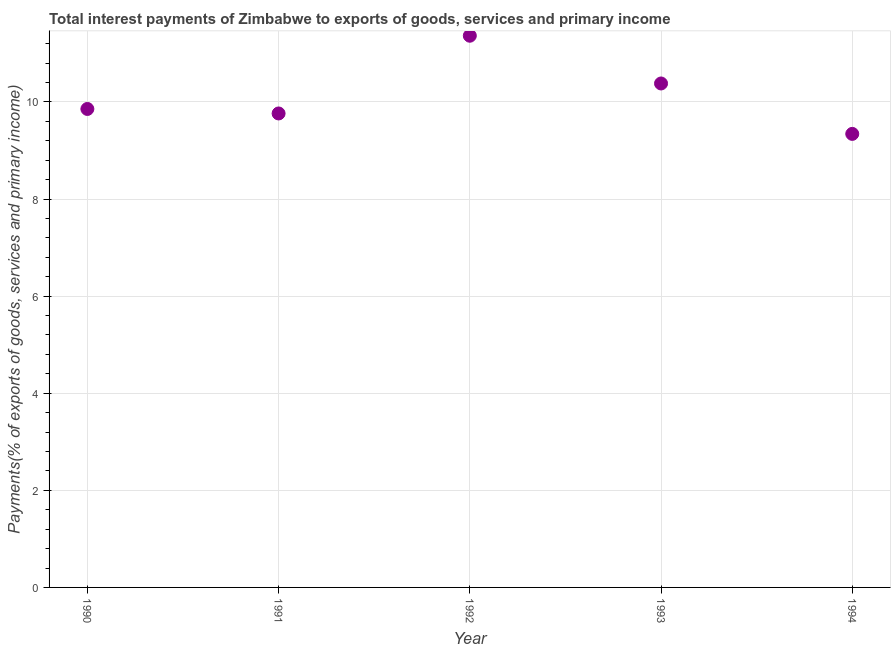What is the total interest payments on external debt in 1990?
Make the answer very short. 9.86. Across all years, what is the maximum total interest payments on external debt?
Your response must be concise. 11.36. Across all years, what is the minimum total interest payments on external debt?
Your answer should be compact. 9.34. In which year was the total interest payments on external debt maximum?
Ensure brevity in your answer.  1992. In which year was the total interest payments on external debt minimum?
Make the answer very short. 1994. What is the sum of the total interest payments on external debt?
Your answer should be very brief. 50.71. What is the difference between the total interest payments on external debt in 1990 and 1993?
Your answer should be compact. -0.53. What is the average total interest payments on external debt per year?
Give a very brief answer. 10.14. What is the median total interest payments on external debt?
Ensure brevity in your answer.  9.86. In how many years, is the total interest payments on external debt greater than 9.2 %?
Give a very brief answer. 5. What is the ratio of the total interest payments on external debt in 1990 to that in 1992?
Give a very brief answer. 0.87. Is the total interest payments on external debt in 1990 less than that in 1993?
Provide a succinct answer. Yes. What is the difference between the highest and the second highest total interest payments on external debt?
Provide a succinct answer. 0.98. Is the sum of the total interest payments on external debt in 1993 and 1994 greater than the maximum total interest payments on external debt across all years?
Offer a terse response. Yes. What is the difference between the highest and the lowest total interest payments on external debt?
Ensure brevity in your answer.  2.02. What is the title of the graph?
Make the answer very short. Total interest payments of Zimbabwe to exports of goods, services and primary income. What is the label or title of the Y-axis?
Your answer should be compact. Payments(% of exports of goods, services and primary income). What is the Payments(% of exports of goods, services and primary income) in 1990?
Make the answer very short. 9.86. What is the Payments(% of exports of goods, services and primary income) in 1991?
Your answer should be compact. 9.76. What is the Payments(% of exports of goods, services and primary income) in 1992?
Your answer should be very brief. 11.36. What is the Payments(% of exports of goods, services and primary income) in 1993?
Ensure brevity in your answer.  10.38. What is the Payments(% of exports of goods, services and primary income) in 1994?
Provide a short and direct response. 9.34. What is the difference between the Payments(% of exports of goods, services and primary income) in 1990 and 1991?
Make the answer very short. 0.09. What is the difference between the Payments(% of exports of goods, services and primary income) in 1990 and 1992?
Provide a short and direct response. -1.51. What is the difference between the Payments(% of exports of goods, services and primary income) in 1990 and 1993?
Your answer should be compact. -0.53. What is the difference between the Payments(% of exports of goods, services and primary income) in 1990 and 1994?
Your answer should be compact. 0.51. What is the difference between the Payments(% of exports of goods, services and primary income) in 1991 and 1992?
Provide a short and direct response. -1.6. What is the difference between the Payments(% of exports of goods, services and primary income) in 1991 and 1993?
Provide a succinct answer. -0.62. What is the difference between the Payments(% of exports of goods, services and primary income) in 1991 and 1994?
Provide a short and direct response. 0.42. What is the difference between the Payments(% of exports of goods, services and primary income) in 1992 and 1993?
Your answer should be very brief. 0.98. What is the difference between the Payments(% of exports of goods, services and primary income) in 1992 and 1994?
Offer a terse response. 2.02. What is the difference between the Payments(% of exports of goods, services and primary income) in 1993 and 1994?
Provide a succinct answer. 1.04. What is the ratio of the Payments(% of exports of goods, services and primary income) in 1990 to that in 1991?
Ensure brevity in your answer.  1.01. What is the ratio of the Payments(% of exports of goods, services and primary income) in 1990 to that in 1992?
Ensure brevity in your answer.  0.87. What is the ratio of the Payments(% of exports of goods, services and primary income) in 1990 to that in 1993?
Your answer should be very brief. 0.95. What is the ratio of the Payments(% of exports of goods, services and primary income) in 1990 to that in 1994?
Make the answer very short. 1.05. What is the ratio of the Payments(% of exports of goods, services and primary income) in 1991 to that in 1992?
Make the answer very short. 0.86. What is the ratio of the Payments(% of exports of goods, services and primary income) in 1991 to that in 1993?
Make the answer very short. 0.94. What is the ratio of the Payments(% of exports of goods, services and primary income) in 1991 to that in 1994?
Your answer should be very brief. 1.04. What is the ratio of the Payments(% of exports of goods, services and primary income) in 1992 to that in 1993?
Provide a short and direct response. 1.09. What is the ratio of the Payments(% of exports of goods, services and primary income) in 1992 to that in 1994?
Provide a succinct answer. 1.22. What is the ratio of the Payments(% of exports of goods, services and primary income) in 1993 to that in 1994?
Ensure brevity in your answer.  1.11. 